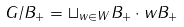<formula> <loc_0><loc_0><loc_500><loc_500>G / B _ { + } = \sqcup _ { w \in W } B _ { + } \cdot w B _ { + }</formula> 